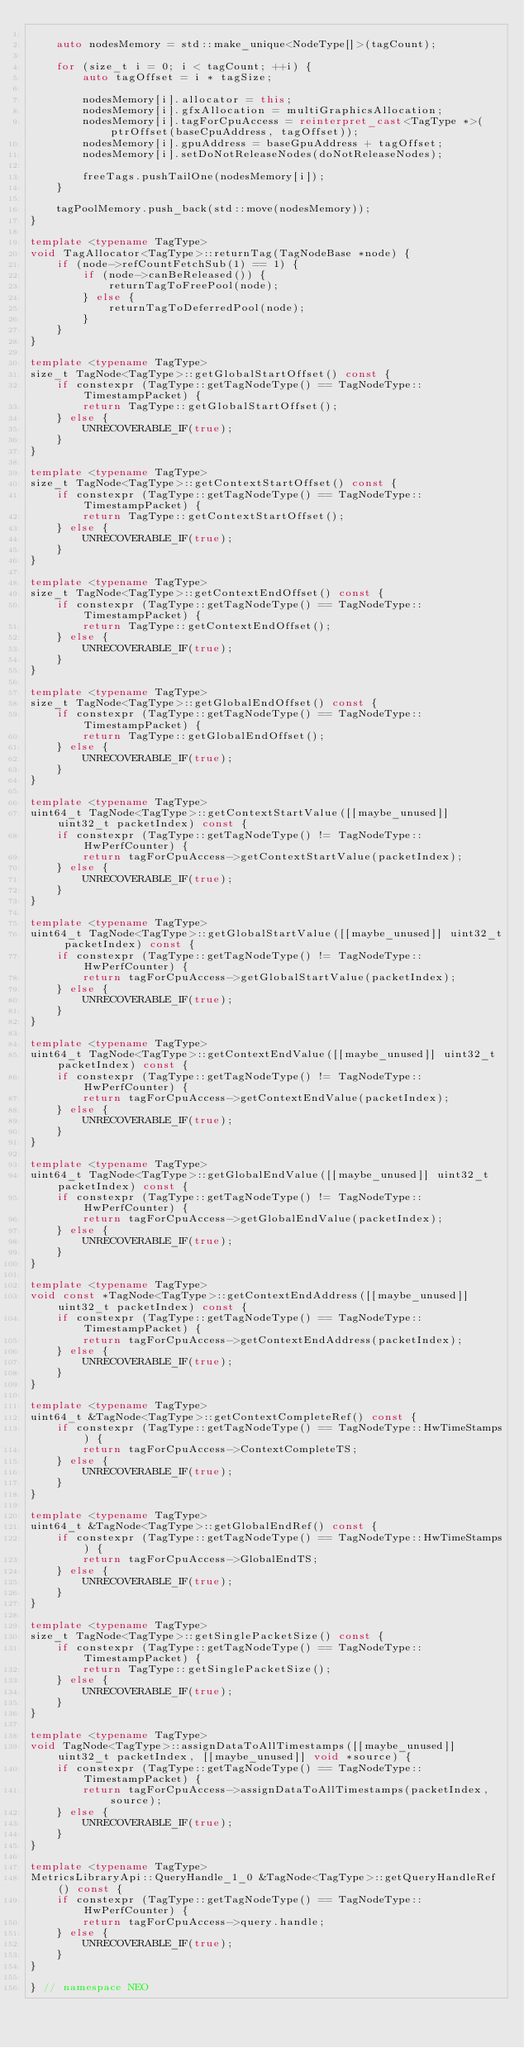Convert code to text. <code><loc_0><loc_0><loc_500><loc_500><_C++_>
    auto nodesMemory = std::make_unique<NodeType[]>(tagCount);

    for (size_t i = 0; i < tagCount; ++i) {
        auto tagOffset = i * tagSize;

        nodesMemory[i].allocator = this;
        nodesMemory[i].gfxAllocation = multiGraphicsAllocation;
        nodesMemory[i].tagForCpuAccess = reinterpret_cast<TagType *>(ptrOffset(baseCpuAddress, tagOffset));
        nodesMemory[i].gpuAddress = baseGpuAddress + tagOffset;
        nodesMemory[i].setDoNotReleaseNodes(doNotReleaseNodes);

        freeTags.pushTailOne(nodesMemory[i]);
    }

    tagPoolMemory.push_back(std::move(nodesMemory));
}

template <typename TagType>
void TagAllocator<TagType>::returnTag(TagNodeBase *node) {
    if (node->refCountFetchSub(1) == 1) {
        if (node->canBeReleased()) {
            returnTagToFreePool(node);
        } else {
            returnTagToDeferredPool(node);
        }
    }
}

template <typename TagType>
size_t TagNode<TagType>::getGlobalStartOffset() const {
    if constexpr (TagType::getTagNodeType() == TagNodeType::TimestampPacket) {
        return TagType::getGlobalStartOffset();
    } else {
        UNRECOVERABLE_IF(true);
    }
}

template <typename TagType>
size_t TagNode<TagType>::getContextStartOffset() const {
    if constexpr (TagType::getTagNodeType() == TagNodeType::TimestampPacket) {
        return TagType::getContextStartOffset();
    } else {
        UNRECOVERABLE_IF(true);
    }
}

template <typename TagType>
size_t TagNode<TagType>::getContextEndOffset() const {
    if constexpr (TagType::getTagNodeType() == TagNodeType::TimestampPacket) {
        return TagType::getContextEndOffset();
    } else {
        UNRECOVERABLE_IF(true);
    }
}

template <typename TagType>
size_t TagNode<TagType>::getGlobalEndOffset() const {
    if constexpr (TagType::getTagNodeType() == TagNodeType::TimestampPacket) {
        return TagType::getGlobalEndOffset();
    } else {
        UNRECOVERABLE_IF(true);
    }
}

template <typename TagType>
uint64_t TagNode<TagType>::getContextStartValue([[maybe_unused]] uint32_t packetIndex) const {
    if constexpr (TagType::getTagNodeType() != TagNodeType::HwPerfCounter) {
        return tagForCpuAccess->getContextStartValue(packetIndex);
    } else {
        UNRECOVERABLE_IF(true);
    }
}

template <typename TagType>
uint64_t TagNode<TagType>::getGlobalStartValue([[maybe_unused]] uint32_t packetIndex) const {
    if constexpr (TagType::getTagNodeType() != TagNodeType::HwPerfCounter) {
        return tagForCpuAccess->getGlobalStartValue(packetIndex);
    } else {
        UNRECOVERABLE_IF(true);
    }
}

template <typename TagType>
uint64_t TagNode<TagType>::getContextEndValue([[maybe_unused]] uint32_t packetIndex) const {
    if constexpr (TagType::getTagNodeType() != TagNodeType::HwPerfCounter) {
        return tagForCpuAccess->getContextEndValue(packetIndex);
    } else {
        UNRECOVERABLE_IF(true);
    }
}

template <typename TagType>
uint64_t TagNode<TagType>::getGlobalEndValue([[maybe_unused]] uint32_t packetIndex) const {
    if constexpr (TagType::getTagNodeType() != TagNodeType::HwPerfCounter) {
        return tagForCpuAccess->getGlobalEndValue(packetIndex);
    } else {
        UNRECOVERABLE_IF(true);
    }
}

template <typename TagType>
void const *TagNode<TagType>::getContextEndAddress([[maybe_unused]] uint32_t packetIndex) const {
    if constexpr (TagType::getTagNodeType() == TagNodeType::TimestampPacket) {
        return tagForCpuAccess->getContextEndAddress(packetIndex);
    } else {
        UNRECOVERABLE_IF(true);
    }
}

template <typename TagType>
uint64_t &TagNode<TagType>::getContextCompleteRef() const {
    if constexpr (TagType::getTagNodeType() == TagNodeType::HwTimeStamps) {
        return tagForCpuAccess->ContextCompleteTS;
    } else {
        UNRECOVERABLE_IF(true);
    }
}

template <typename TagType>
uint64_t &TagNode<TagType>::getGlobalEndRef() const {
    if constexpr (TagType::getTagNodeType() == TagNodeType::HwTimeStamps) {
        return tagForCpuAccess->GlobalEndTS;
    } else {
        UNRECOVERABLE_IF(true);
    }
}

template <typename TagType>
size_t TagNode<TagType>::getSinglePacketSize() const {
    if constexpr (TagType::getTagNodeType() == TagNodeType::TimestampPacket) {
        return TagType::getSinglePacketSize();
    } else {
        UNRECOVERABLE_IF(true);
    }
}

template <typename TagType>
void TagNode<TagType>::assignDataToAllTimestamps([[maybe_unused]] uint32_t packetIndex, [[maybe_unused]] void *source) {
    if constexpr (TagType::getTagNodeType() == TagNodeType::TimestampPacket) {
        return tagForCpuAccess->assignDataToAllTimestamps(packetIndex, source);
    } else {
        UNRECOVERABLE_IF(true);
    }
}

template <typename TagType>
MetricsLibraryApi::QueryHandle_1_0 &TagNode<TagType>::getQueryHandleRef() const {
    if constexpr (TagType::getTagNodeType() == TagNodeType::HwPerfCounter) {
        return tagForCpuAccess->query.handle;
    } else {
        UNRECOVERABLE_IF(true);
    }
}

} // namespace NEO
</code> 